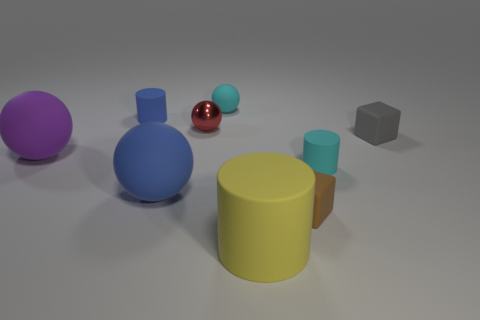Add 1 small spheres. How many objects exist? 10 Subtract all cylinders. How many objects are left? 6 Subtract 0 brown balls. How many objects are left? 9 Subtract all purple cylinders. Subtract all small blue matte objects. How many objects are left? 8 Add 3 tiny cylinders. How many tiny cylinders are left? 5 Add 5 large blue shiny things. How many large blue shiny things exist? 5 